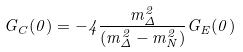Convert formula to latex. <formula><loc_0><loc_0><loc_500><loc_500>G _ { C } ( 0 ) = - 4 \frac { m ^ { 2 } _ { \Delta } } { ( m ^ { 2 } _ { \Delta } - m ^ { 2 } _ { N } ) } G _ { E } ( 0 )</formula> 